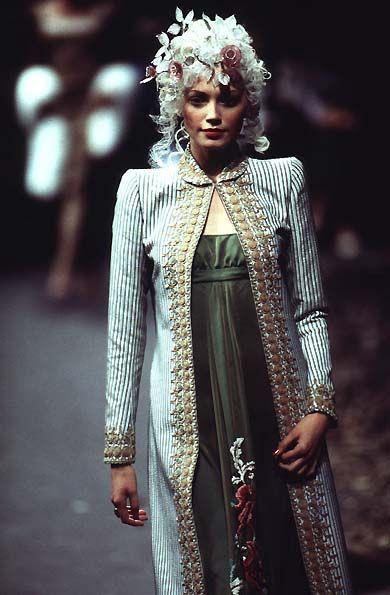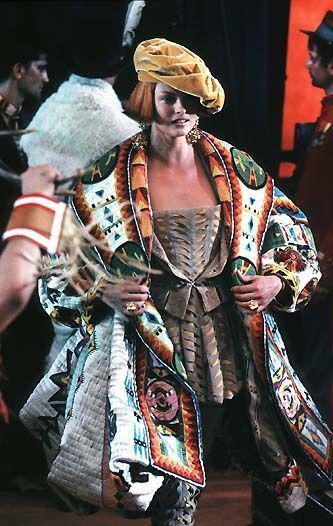The first image is the image on the left, the second image is the image on the right. For the images shown, is this caption "You cannot see the face of at least one of the models." true? Answer yes or no. No. The first image is the image on the left, the second image is the image on the right. Considering the images on both sides, is "At least one front view and one back view of fashions are shown by models." valid? Answer yes or no. No. 